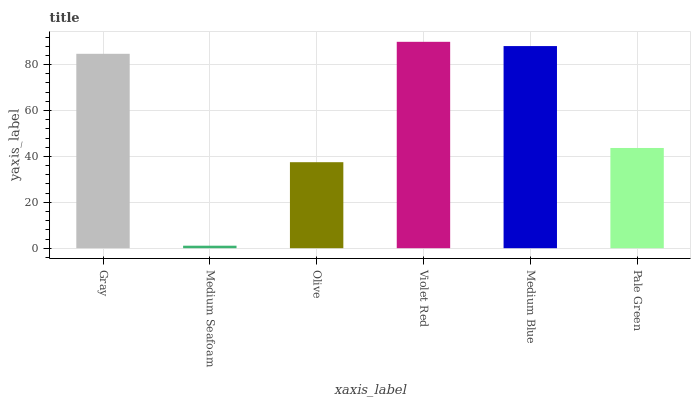Is Olive the minimum?
Answer yes or no. No. Is Olive the maximum?
Answer yes or no. No. Is Olive greater than Medium Seafoam?
Answer yes or no. Yes. Is Medium Seafoam less than Olive?
Answer yes or no. Yes. Is Medium Seafoam greater than Olive?
Answer yes or no. No. Is Olive less than Medium Seafoam?
Answer yes or no. No. Is Gray the high median?
Answer yes or no. Yes. Is Pale Green the low median?
Answer yes or no. Yes. Is Pale Green the high median?
Answer yes or no. No. Is Violet Red the low median?
Answer yes or no. No. 